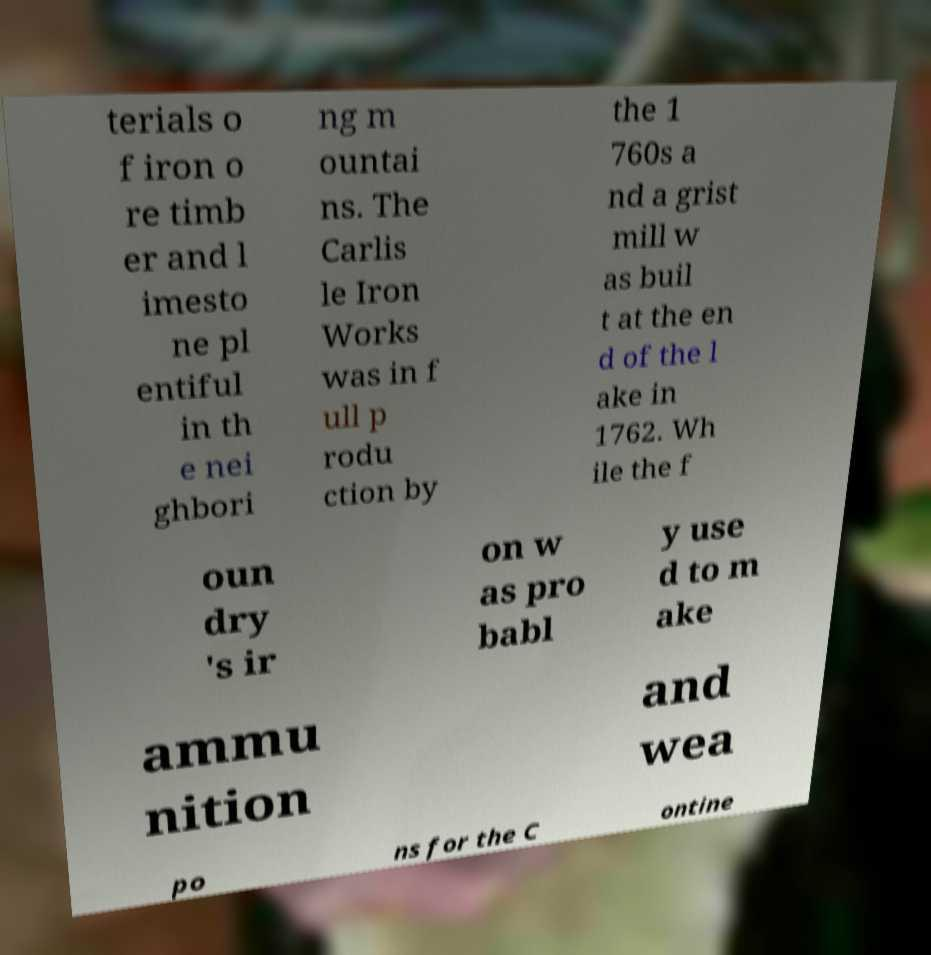For documentation purposes, I need the text within this image transcribed. Could you provide that? terials o f iron o re timb er and l imesto ne pl entiful in th e nei ghbori ng m ountai ns. The Carlis le Iron Works was in f ull p rodu ction by the 1 760s a nd a grist mill w as buil t at the en d of the l ake in 1762. Wh ile the f oun dry 's ir on w as pro babl y use d to m ake ammu nition and wea po ns for the C ontine 